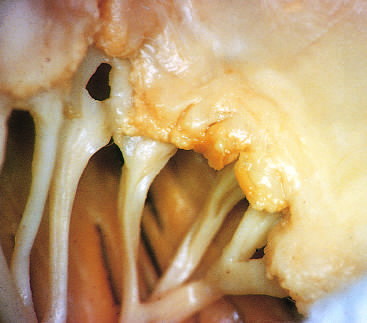what are visible along the line of closure of the mitral valve leaflets?
Answer the question using a single word or phrase. Small vegetations 